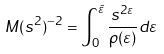Convert formula to latex. <formula><loc_0><loc_0><loc_500><loc_500>M ( s ^ { 2 } ) ^ { - 2 } = \int _ { 0 } ^ { \bar { \varepsilon } } \frac { s ^ { 2 \varepsilon } } { \rho ( \varepsilon ) } d \varepsilon</formula> 